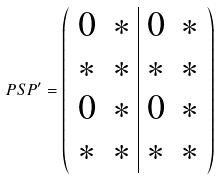Convert formula to latex. <formula><loc_0><loc_0><loc_500><loc_500>P S P ^ { \prime } = \left ( \begin{array} { c c | c c } 0 & * & 0 & * \\ * & * & * & * \\ 0 & * & 0 & * \\ * & * & * & * \end{array} \right )</formula> 